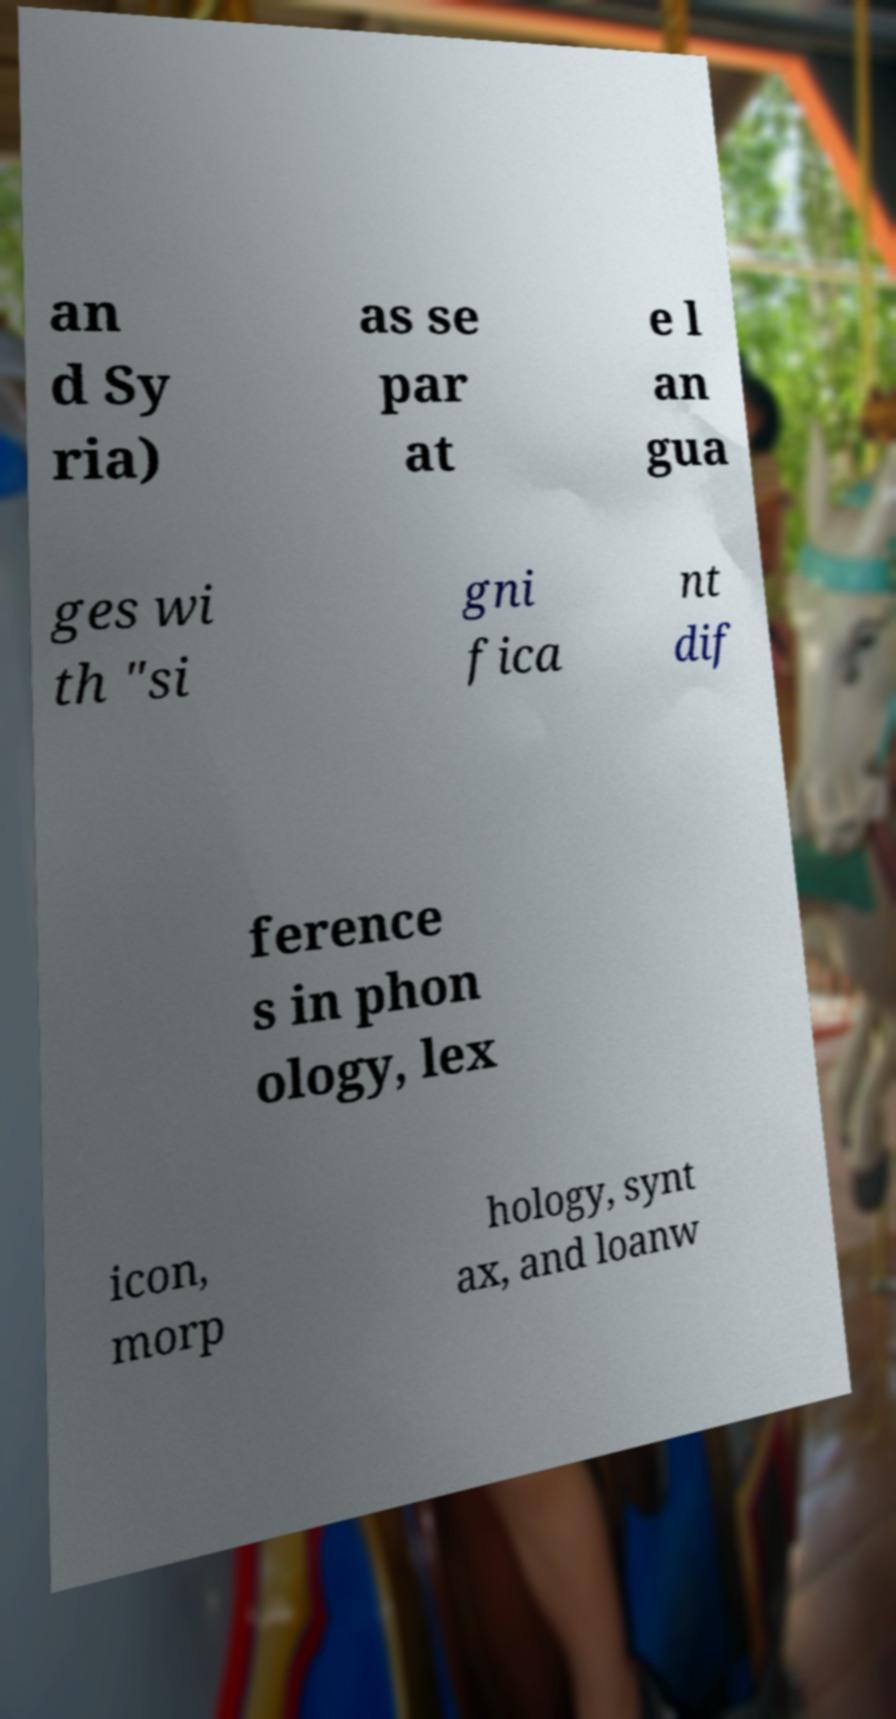I need the written content from this picture converted into text. Can you do that? an d Sy ria) as se par at e l an gua ges wi th "si gni fica nt dif ference s in phon ology, lex icon, morp hology, synt ax, and loanw 